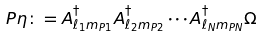<formula> <loc_0><loc_0><loc_500><loc_500>P \eta \colon = A ^ { \dag } _ { \ell _ { 1 } m _ { P 1 } } A ^ { \dag } _ { \ell _ { 2 } m _ { P 2 } } \cdots A ^ { \dag } _ { \ell _ { N } m _ { P N } } \Omega</formula> 